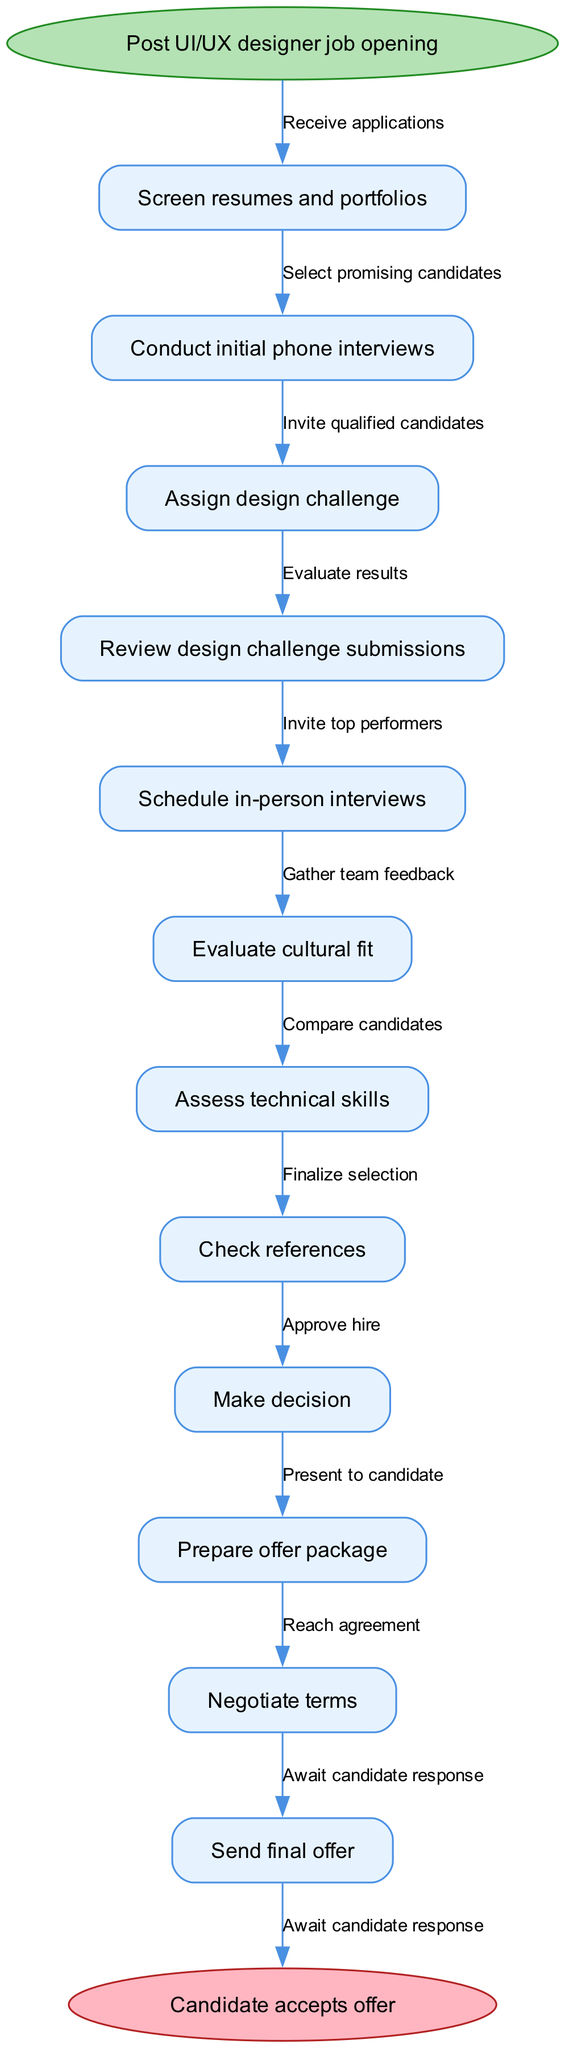What is the first step in the recruitment process? The first step listed in the diagram is "Post UI/UX designer job opening." This is indicated as the starting point of the flow chart.
Answer: Post UI/UX designer job opening How many nodes are there in the diagram? By counting each of the listed nodes in the recruitment process (including the start and end nodes), there are a total of 12 nodes.
Answer: 12 What action follows "Conduct initial phone interviews"? After "Conduct initial phone interviews," the next action in the flow is "Assign design challenge." This can be observed as a connection in the flow from the initial interview to the design challenge.
Answer: Assign design challenge What is the final step in the recruitment process? The last step in the diagram is "Candidate accepts offer," which is indicated as the endpoint of the flow chart.
Answer: Candidate accepts offer How many edges are there in the recruitment process diagram? Counting the connections between all nodes, there are 11 edges representing the actions taken throughout the recruitment process.
Answer: 11 What action is taken after "Check references"? Following the "Check references" step, the next action in the process is "Make decision." This is shown as the subsequent connection in the flow chart.
Answer: Make decision Which node corresponds with the edge labeled "Evaluate results"? The edge labeled "Evaluate results" connects the nodes "Assign design challenge" and "Review design challenge submissions," indicating that results from the design challenge are evaluated after they are assigned.
Answer: Review design challenge submissions What needs to happen before "Send final offer"? Before "Send final offer," the steps that must occur are "Negotiate terms" and "Prepare offer package." Thus, these steps are prerequisites for sending the final offer to the candidate.
Answer: Negotiate terms, Prepare offer package 